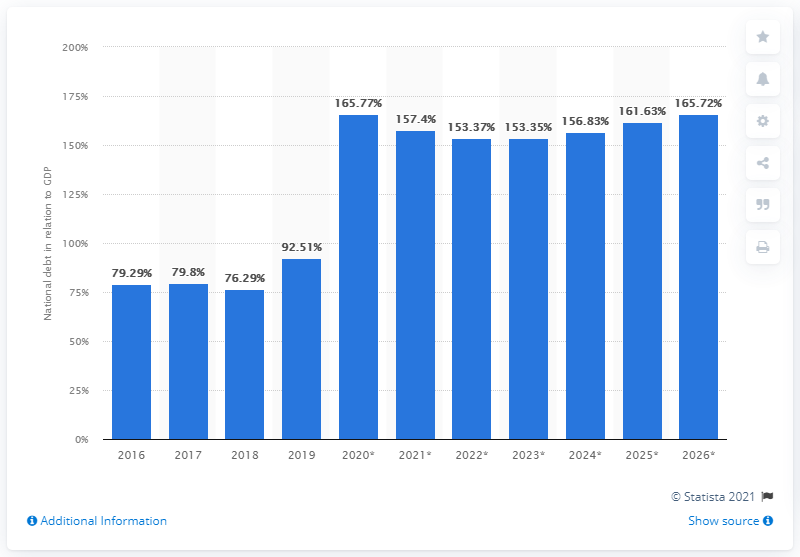Give some essential details in this illustration. In 2019, the national debt of Suriname was 92.51. 